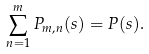Convert formula to latex. <formula><loc_0><loc_0><loc_500><loc_500>\sum _ { n = 1 } ^ { m } P _ { m , n } ( s ) = P ( s ) .</formula> 